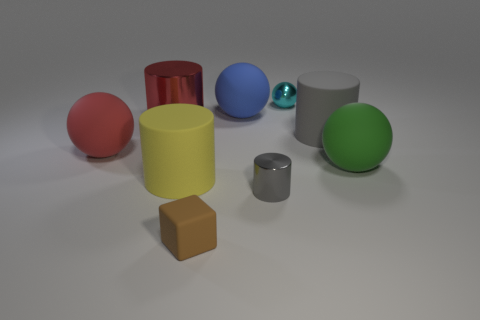Subtract all small cyan spheres. How many spheres are left? 3 Add 1 tiny cyan metal objects. How many objects exist? 10 Subtract all red cylinders. How many cylinders are left? 3 Subtract all gray balls. Subtract all brown blocks. How many balls are left? 4 Subtract all cubes. How many objects are left? 8 Subtract 1 red cylinders. How many objects are left? 8 Subtract all big cyan matte spheres. Subtract all cyan things. How many objects are left? 8 Add 7 tiny cyan shiny spheres. How many tiny cyan shiny spheres are left? 8 Add 5 small yellow blocks. How many small yellow blocks exist? 5 